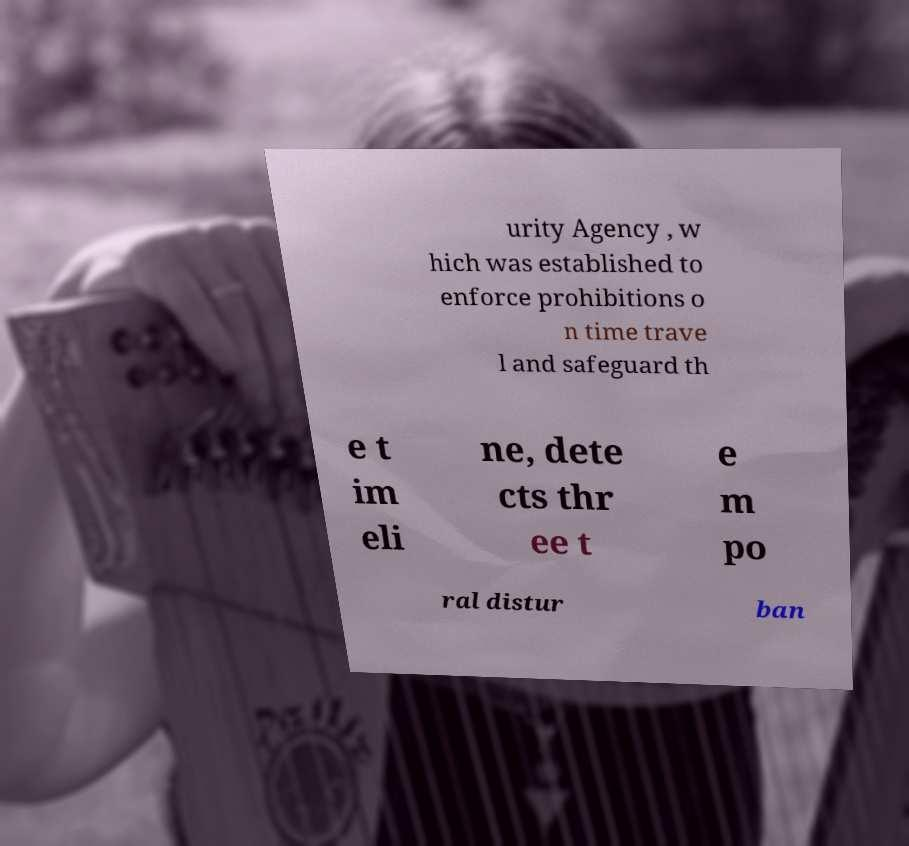Could you extract and type out the text from this image? urity Agency , w hich was established to enforce prohibitions o n time trave l and safeguard th e t im eli ne, dete cts thr ee t e m po ral distur ban 